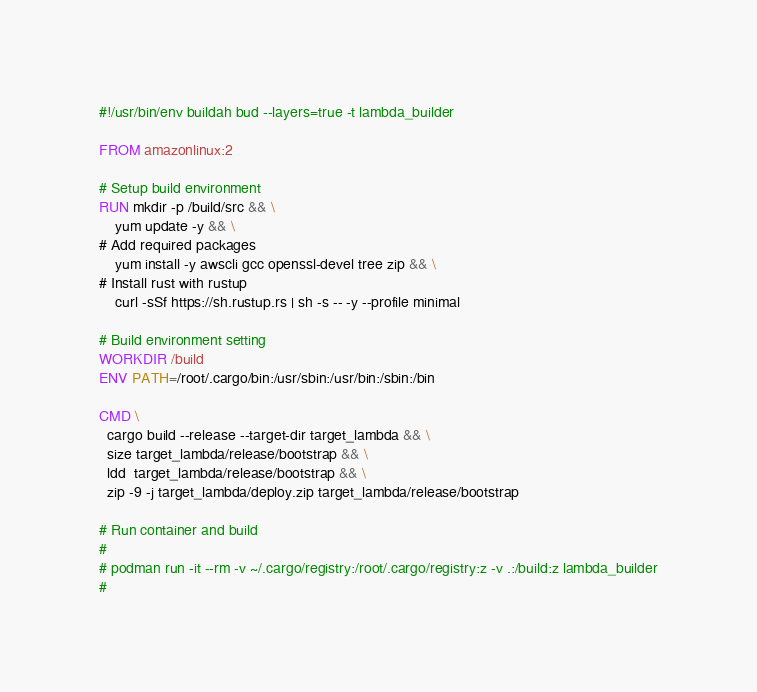Convert code to text. <code><loc_0><loc_0><loc_500><loc_500><_Dockerfile_>#!/usr/bin/env buildah bud --layers=true -t lambda_builder

FROM amazonlinux:2

# Setup build environment
RUN mkdir -p /build/src && \
    yum update -y && \
# Add required packages
    yum install -y awscli gcc openssl-devel tree zip && \
# Install rust with rustup
    curl -sSf https://sh.rustup.rs | sh -s -- -y --profile minimal

# Build environment setting
WORKDIR /build
ENV PATH=/root/.cargo/bin:/usr/sbin:/usr/bin:/sbin:/bin

CMD \
  cargo build --release --target-dir target_lambda && \
  size target_lambda/release/bootstrap && \
  ldd  target_lambda/release/bootstrap && \
  zip -9 -j target_lambda/deploy.zip target_lambda/release/bootstrap

# Run container and build
#
# podman run -it --rm -v ~/.cargo/registry:/root/.cargo/registry:z -v .:/build:z lambda_builder
#

</code> 